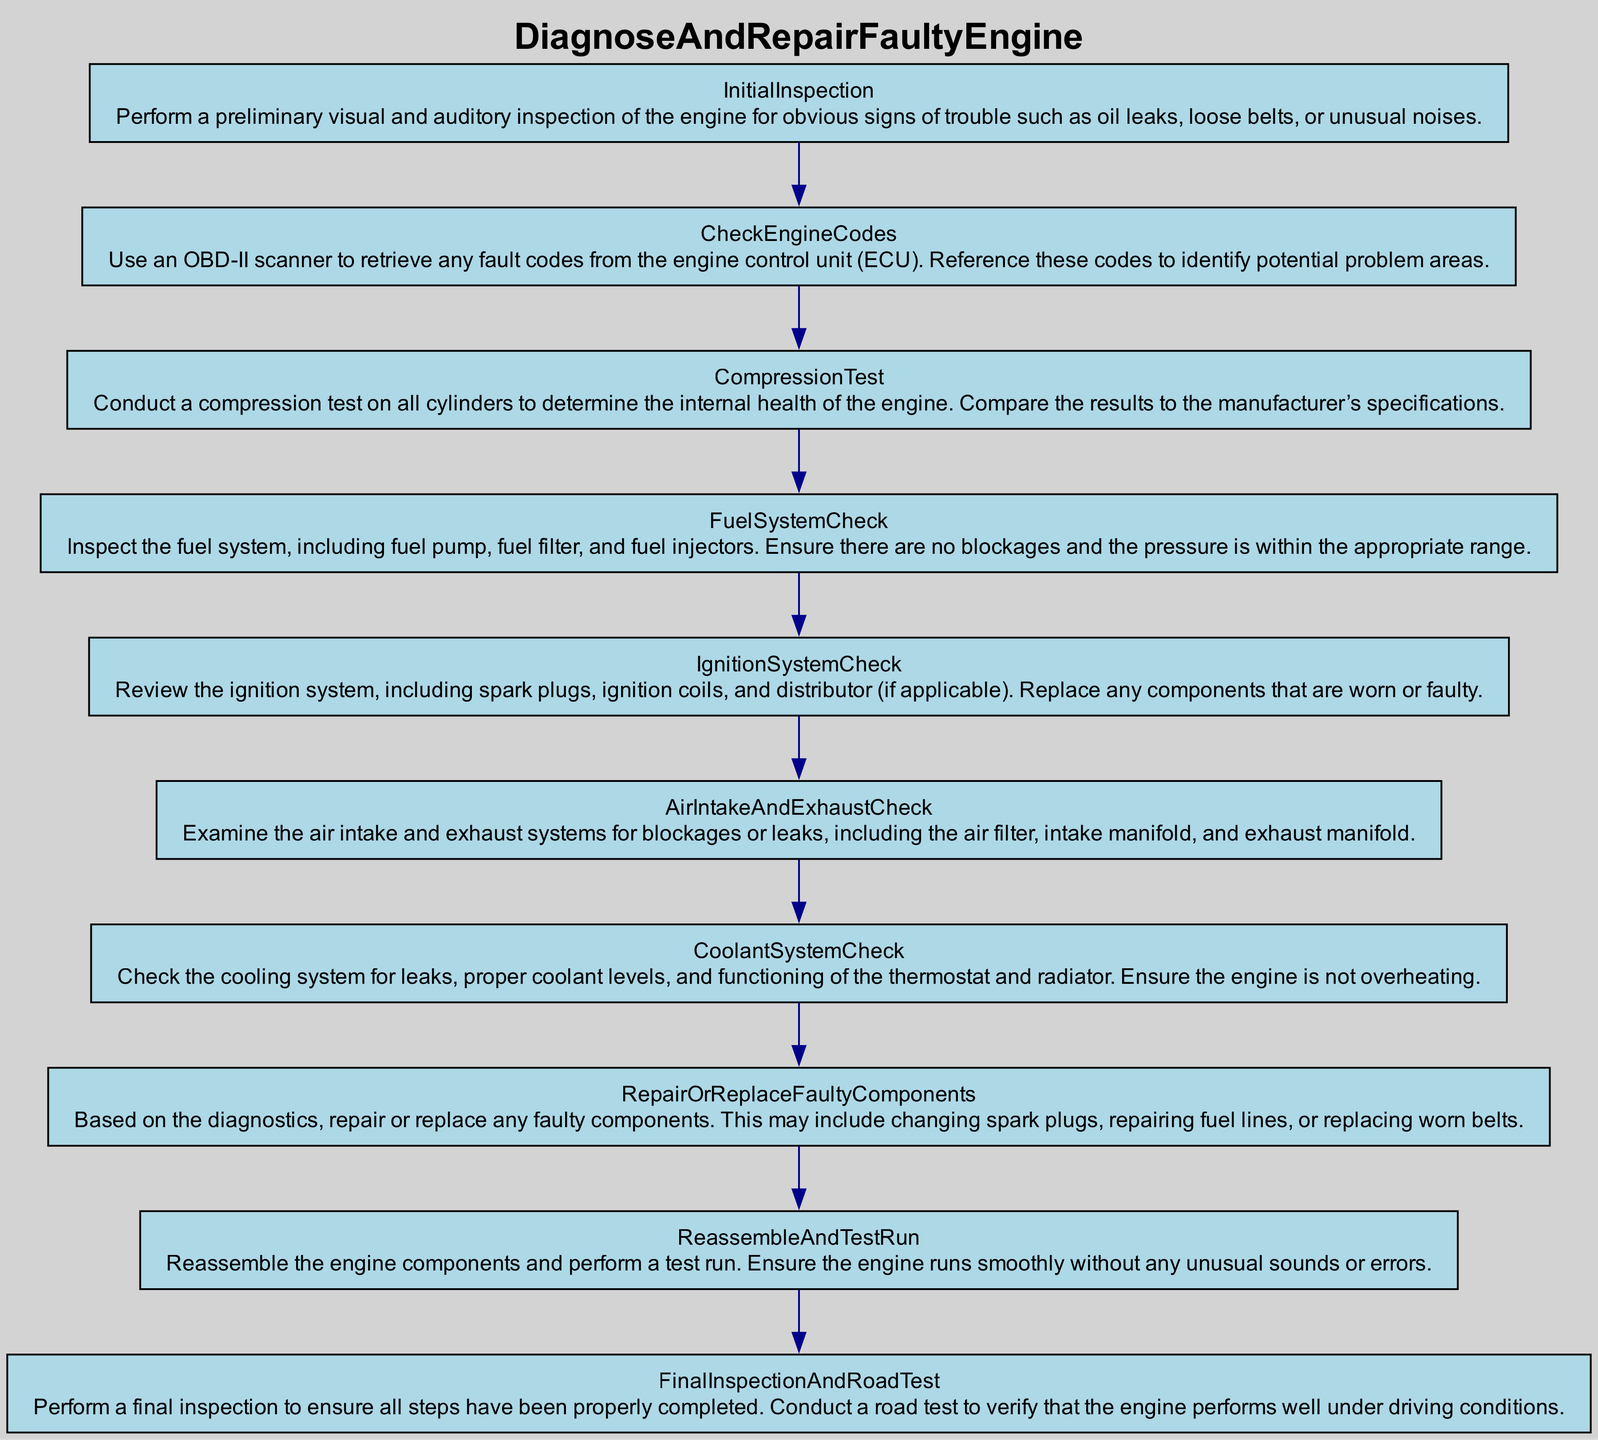What is the first step in the diagram? The first step is "Initial Inspection," as it is the starting point of the flowchart, leading to the subsequent steps.
Answer: Initial Inspection How many steps are there in total? By counting each of the individual steps listed in the diagram, there are ten distinct steps in the process.
Answer: 10 What follows the "Compression Test"? The "Fuel System Check" follows the "Compression Test," indicating the next action to be taken after that particular step.
Answer: Fuel System Check Which step includes checking for leaks and levels? The "Coolant System Check" includes inspecting for leaks, proper coolant levels, and functionality of the thermostat and radiator.
Answer: Coolant System Check What is the last step in the process? The last step is "Final Inspection and Road Test," as it comes after all previous diagnostic and repair actions have been completed.
Answer: Final Inspection and Road Test How many checks involve the system inspections? There are four checks that involve inspecting systems: Fuel System Check, Ignition System Check, Air Intake and Exhaust Check, and Coolant System Check, totaling four inspections.
Answer: 4 What components are repaired or replaced in the step following "Air Intake and Exhaust Check"? The step "Repair or Replace Faulty Components" specifies that it focuses on addressing the issues identified in the earlier steps by repairing or replacing components as necessary.
Answer: Repair or Replace Faulty Components What is the purpose of the "Check Engine Codes" step? The "Check Engine Codes" step is designed to utilize an OBD-II scanner to gather fault codes from the engine control unit, which helps identify potential problem areas.
Answer: Identify potential problem areas What action is taken directly after diagnosing issues? The action taken after diagnosing issues is "Repair or Replace Faulty Components," which refers to addressing any problems that have been found during the diagnosis.
Answer: Repair or Replace Faulty Components 